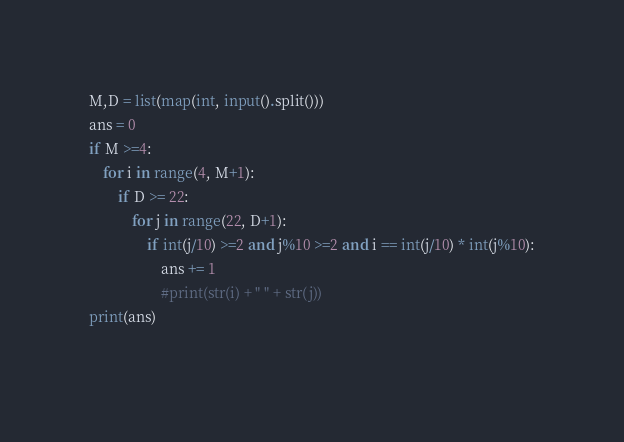Convert code to text. <code><loc_0><loc_0><loc_500><loc_500><_Python_>M,D = list(map(int, input().split()))
ans = 0
if M >=4:
    for i in range(4, M+1):
        if D >= 22:
            for j in range(22, D+1):
                if int(j/10) >=2 and j%10 >=2 and i == int(j/10) * int(j%10):
                    ans += 1
                    #print(str(i) + " " + str(j))
print(ans)
    </code> 